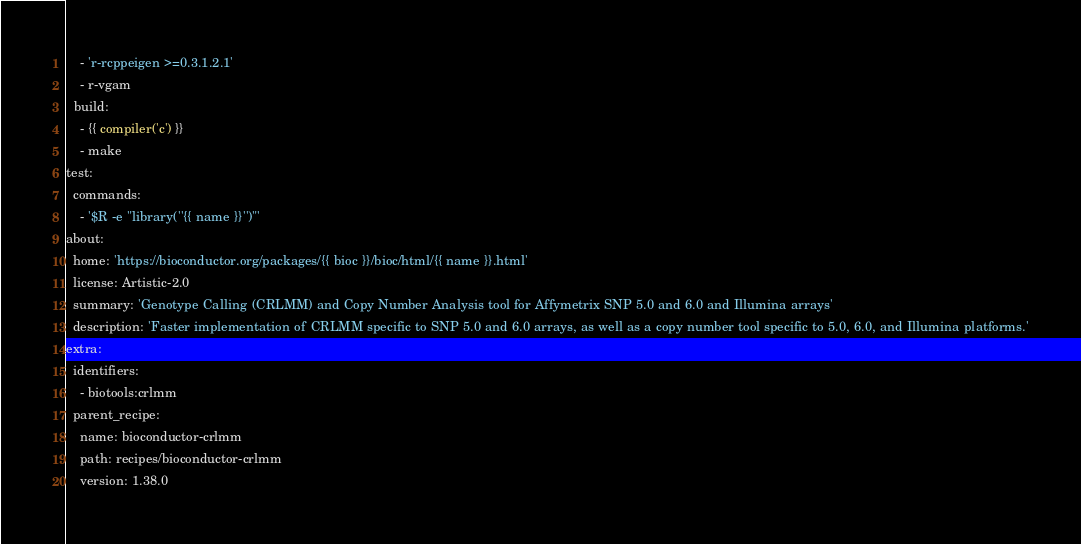<code> <loc_0><loc_0><loc_500><loc_500><_YAML_>    - 'r-rcppeigen >=0.3.1.2.1'
    - r-vgam
  build:
    - {{ compiler('c') }}
    - make
test:
  commands:
    - '$R -e "library(''{{ name }}'')"'
about:
  home: 'https://bioconductor.org/packages/{{ bioc }}/bioc/html/{{ name }}.html'
  license: Artistic-2.0
  summary: 'Genotype Calling (CRLMM) and Copy Number Analysis tool for Affymetrix SNP 5.0 and 6.0 and Illumina arrays'
  description: 'Faster implementation of CRLMM specific to SNP 5.0 and 6.0 arrays, as well as a copy number tool specific to 5.0, 6.0, and Illumina platforms.'
extra:
  identifiers:
    - biotools:crlmm
  parent_recipe:
    name: bioconductor-crlmm
    path: recipes/bioconductor-crlmm
    version: 1.38.0

</code> 